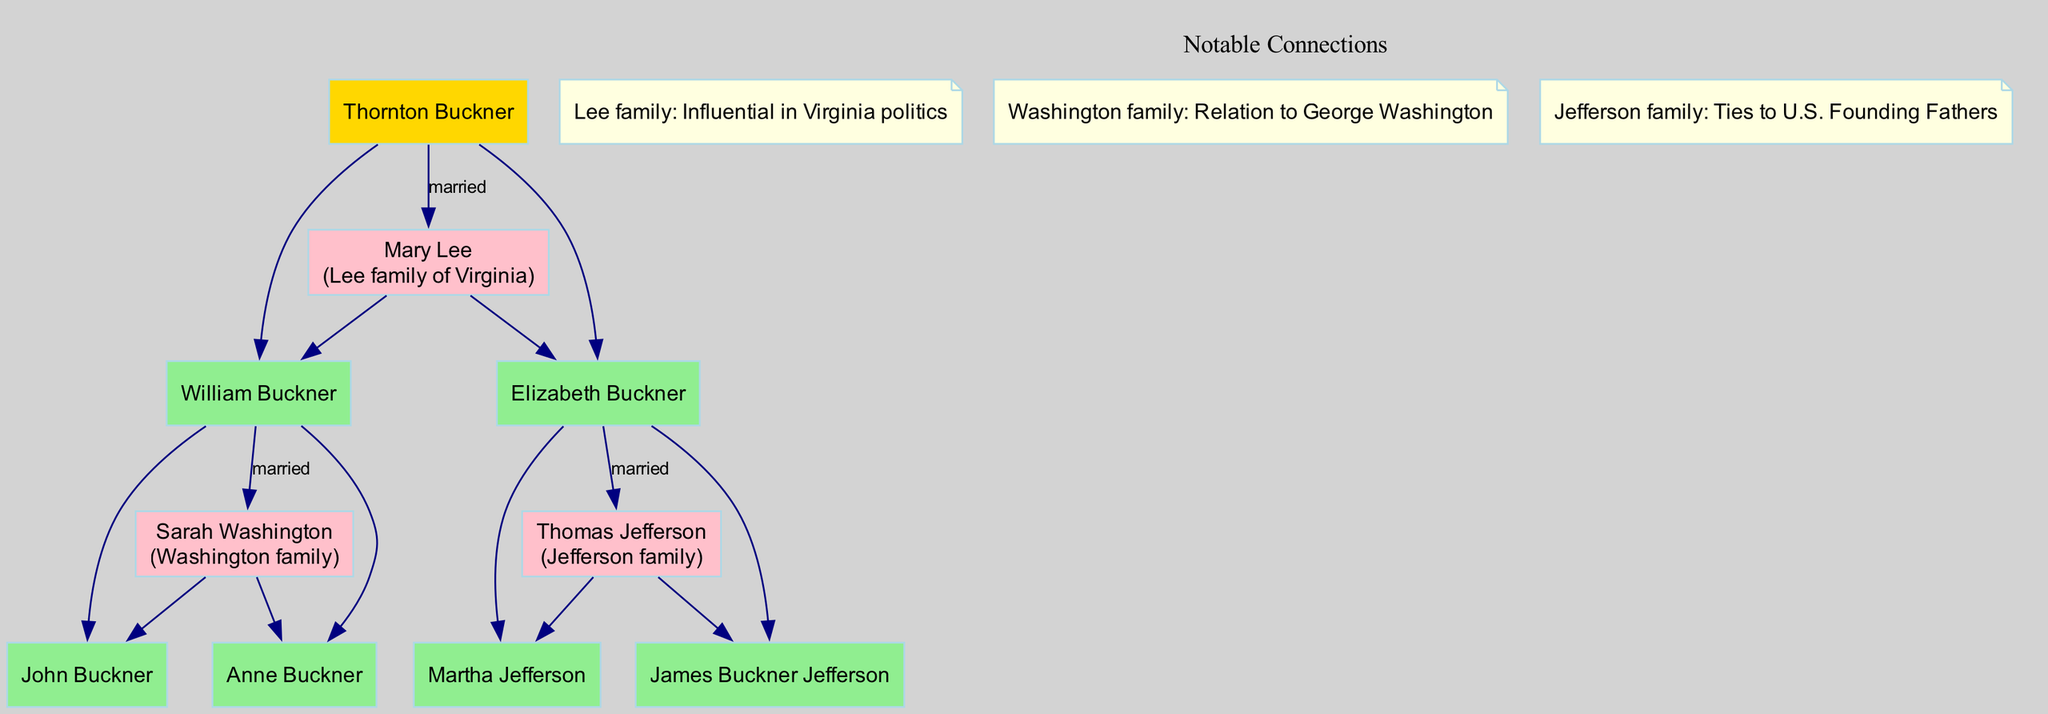What is the root name of the family tree? The family tree begins with the root node labeled "Thornton Buckner." This is identified as the central figure from which the family lineage is traced.
Answer: Thornton Buckner How many children does Thornton Buckner have? In the diagram, Thornton Buckner is shown to have two children, William Buckner and Elizabeth Buckner, as indicated by the direct connections leading from his node.
Answer: 2 Which family is associated with Elizabeth Buckner's spouse? Elizabeth Buckner is married to Thomas Jefferson, who is labeled as belonging to the Jefferson family in the diagram. This connection identifies the notable family associated with her marriage.
Answer: Jefferson family Who is the spouse of William Buckner? William Buckner is married to Sarah Washington, and this is represented in the diagram with a direct connection to his node. The name "Sarah Washington" is accompanied by the label indicating her family, the Washington family.
Answer: Sarah Washington What notable family has a relation to George Washington? The diagram makes a clear connection by stating that the Washington family is related to George Washington, indicated alongside Sarah Washington's node. This highlights the significance of her family in the context of American history.
Answer: Washington family How many descendants does Elizabeth Buckner have? Elizabeth Buckner has two descendants, indicated in the diagram. The children shown are Martha Jefferson and James Buckner Jefferson, which confirms the lineage stemming from her.
Answer: 2 Which families are recognized for their influence in Virginia politics based on this diagram? The Lee family is highlighted in the diagram as influential in Virginia politics. This is derived from the notable connections section, specifically noting the importance of this family within the historical context.
Answer: Lee family What is the connection between William Buckner and the Washington family? William Buckner is married to Sarah Washington, who is identified as the daughter of the Washington family, showing a direct familial link between William and this prominent lineage.
Answer: Married to Sarah Washington Which child of William Buckner is named John? John Buckner is identified as one of the children of William Buckner, as depicted in the tree structure that shows his direct descendant line under William Buckner's node.
Answer: John Buckner 